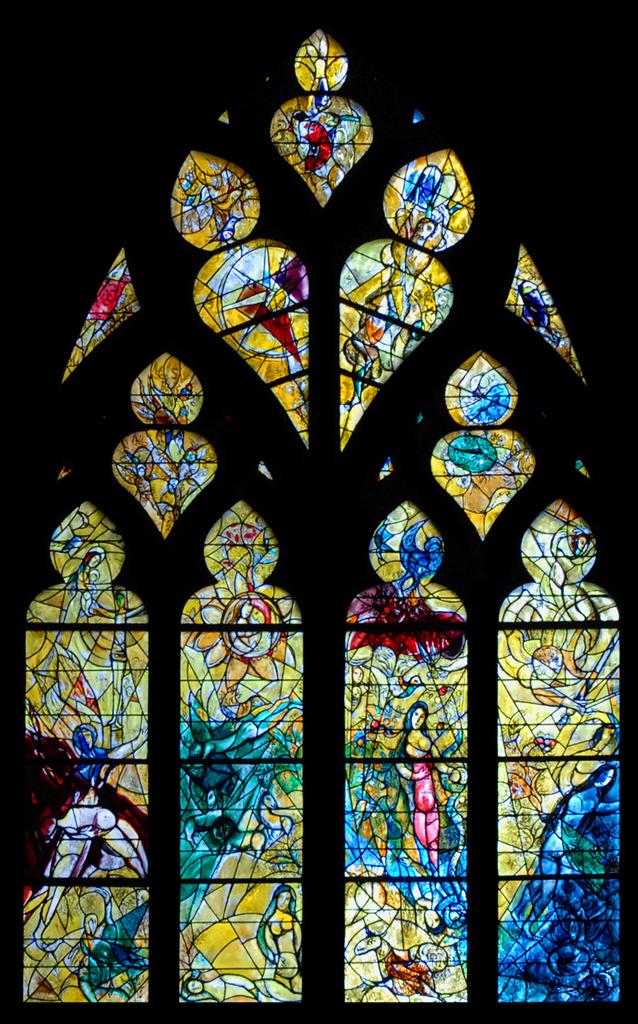What can be seen in the image related to a view or opening? There is a window in the image. What is unique about the window in the image? The window has a glass painting. What time is indicated by the hour hand on the clock in the image? There is no clock present in the image, so we cannot determine the time. 